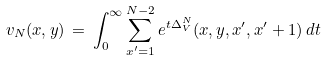<formula> <loc_0><loc_0><loc_500><loc_500>v _ { N } ( x , y ) \, = \, \int _ { 0 } ^ { \infty } \sum _ { x ^ { \prime } = 1 } ^ { N - 2 } e ^ { t \Delta _ { V } ^ { N } } ( x , y , x ^ { \prime } , x ^ { \prime } + 1 ) \, d t</formula> 